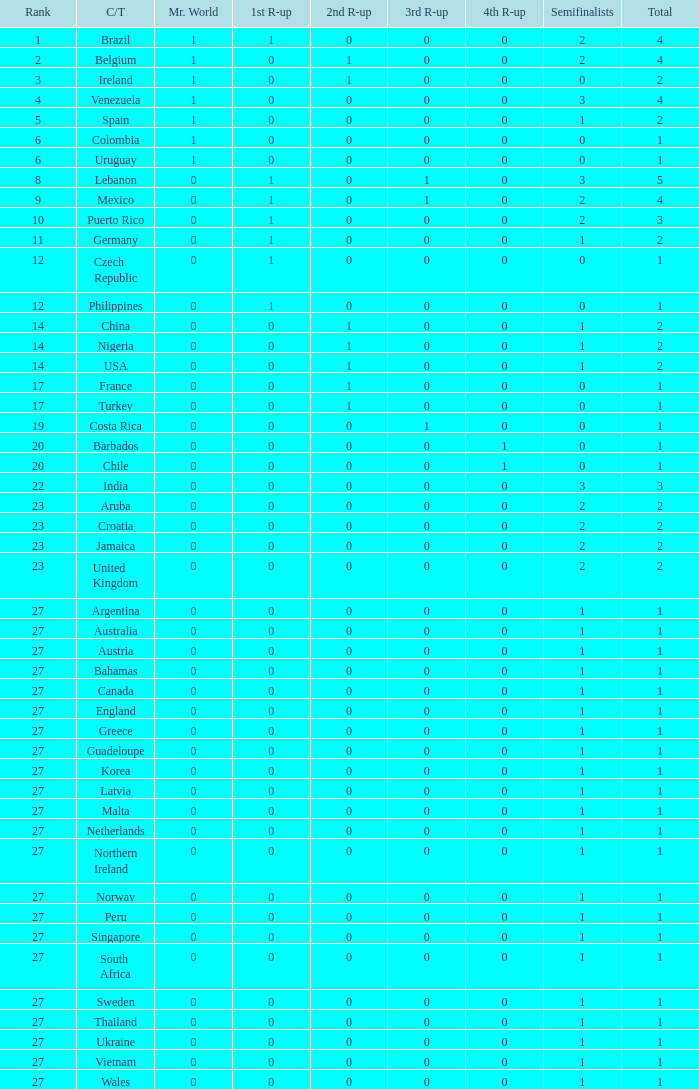How many 3rd runner up values does Turkey have? 1.0. Write the full table. {'header': ['Rank', 'C/T', 'Mr. World', '1st R-up', '2nd R-up', '3rd R-up', '4th R-up', 'Semifinalists', 'Total'], 'rows': [['1', 'Brazil', '1', '1', '0', '0', '0', '2', '4'], ['2', 'Belgium', '1', '0', '1', '0', '0', '2', '4'], ['3', 'Ireland', '1', '0', '1', '0', '0', '0', '2'], ['4', 'Venezuela', '1', '0', '0', '0', '0', '3', '4'], ['5', 'Spain', '1', '0', '0', '0', '0', '1', '2'], ['6', 'Colombia', '1', '0', '0', '0', '0', '0', '1'], ['6', 'Uruguay', '1', '0', '0', '0', '0', '0', '1'], ['8', 'Lebanon', '0', '1', '0', '1', '0', '3', '5'], ['9', 'Mexico', '0', '1', '0', '1', '0', '2', '4'], ['10', 'Puerto Rico', '0', '1', '0', '0', '0', '2', '3'], ['11', 'Germany', '0', '1', '0', '0', '0', '1', '2'], ['12', 'Czech Republic', '0', '1', '0', '0', '0', '0', '1'], ['12', 'Philippines', '0', '1', '0', '0', '0', '0', '1'], ['14', 'China', '0', '0', '1', '0', '0', '1', '2'], ['14', 'Nigeria', '0', '0', '1', '0', '0', '1', '2'], ['14', 'USA', '0', '0', '1', '0', '0', '1', '2'], ['17', 'France', '0', '0', '1', '0', '0', '0', '1'], ['17', 'Turkey', '0', '0', '1', '0', '0', '0', '1'], ['19', 'Costa Rica', '0', '0', '0', '1', '0', '0', '1'], ['20', 'Barbados', '0', '0', '0', '0', '1', '0', '1'], ['20', 'Chile', '0', '0', '0', '0', '1', '0', '1'], ['22', 'India', '0', '0', '0', '0', '0', '3', '3'], ['23', 'Aruba', '0', '0', '0', '0', '0', '2', '2'], ['23', 'Croatia', '0', '0', '0', '0', '0', '2', '2'], ['23', 'Jamaica', '0', '0', '0', '0', '0', '2', '2'], ['23', 'United Kingdom', '0', '0', '0', '0', '0', '2', '2'], ['27', 'Argentina', '0', '0', '0', '0', '0', '1', '1'], ['27', 'Australia', '0', '0', '0', '0', '0', '1', '1'], ['27', 'Austria', '0', '0', '0', '0', '0', '1', '1'], ['27', 'Bahamas', '0', '0', '0', '0', '0', '1', '1'], ['27', 'Canada', '0', '0', '0', '0', '0', '1', '1'], ['27', 'England', '0', '0', '0', '0', '0', '1', '1'], ['27', 'Greece', '0', '0', '0', '0', '0', '1', '1'], ['27', 'Guadeloupe', '0', '0', '0', '0', '0', '1', '1'], ['27', 'Korea', '0', '0', '0', '0', '0', '1', '1'], ['27', 'Latvia', '0', '0', '0', '0', '0', '1', '1'], ['27', 'Malta', '0', '0', '0', '0', '0', '1', '1'], ['27', 'Netherlands', '0', '0', '0', '0', '0', '1', '1'], ['27', 'Northern Ireland', '0', '0', '0', '0', '0', '1', '1'], ['27', 'Norway', '0', '0', '0', '0', '0', '1', '1'], ['27', 'Peru', '0', '0', '0', '0', '0', '1', '1'], ['27', 'Singapore', '0', '0', '0', '0', '0', '1', '1'], ['27', 'South Africa', '0', '0', '0', '0', '0', '1', '1'], ['27', 'Sweden', '0', '0', '0', '0', '0', '1', '1'], ['27', 'Thailand', '0', '0', '0', '0', '0', '1', '1'], ['27', 'Ukraine', '0', '0', '0', '0', '0', '1', '1'], ['27', 'Vietnam', '0', '0', '0', '0', '0', '1', '1'], ['27', 'Wales', '0', '0', '0', '0', '0', '1', '1']]} 